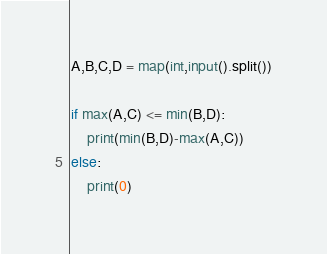Convert code to text. <code><loc_0><loc_0><loc_500><loc_500><_Python_>A,B,C,D = map(int,input().split())

if max(A,C) <= min(B,D):
    print(min(B,D)-max(A,C))
else:
    print(0)</code> 